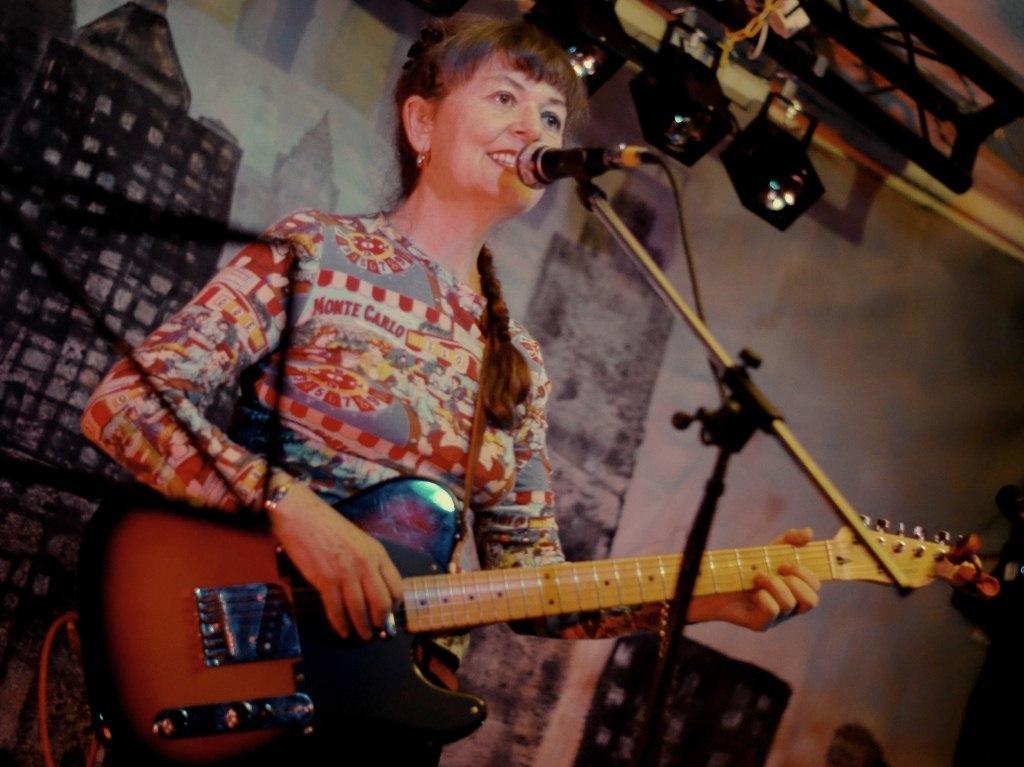How would you summarize this image in a sentence or two? There is a woman holding a guitar and playing. In front of her there is a mic and mic stand. In the back there is a wall. Also there are lights. 